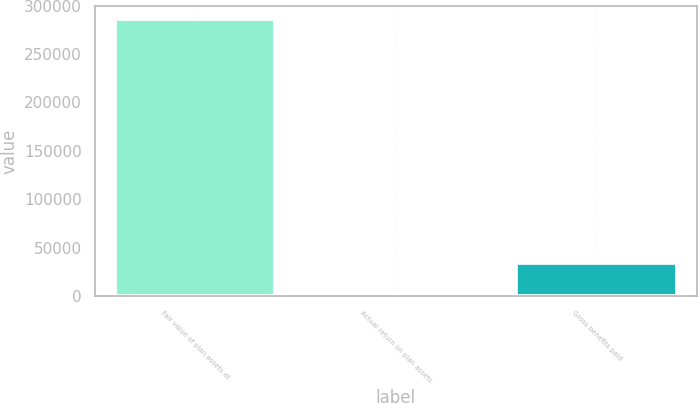<chart> <loc_0><loc_0><loc_500><loc_500><bar_chart><fcel>Fair value of plan assets at<fcel>Actual return on plan assets<fcel>Gross benefits paid<nl><fcel>285777<fcel>1899<fcel>34486<nl></chart> 